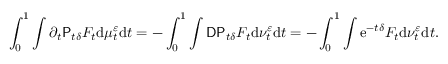Convert formula to latex. <formula><loc_0><loc_0><loc_500><loc_500>\int _ { 0 } ^ { 1 } \int \partial _ { t } P _ { t \delta } F _ { t } d \mu _ { t } ^ { \varepsilon } d t = - \int _ { 0 } ^ { 1 } \int D P _ { t \delta } F _ { t } d \nu _ { t } ^ { \varepsilon } d t = - \int _ { 0 } ^ { 1 } \int e ^ { - t \delta } F _ { t } d \nu _ { t } ^ { \varepsilon } d t .</formula> 